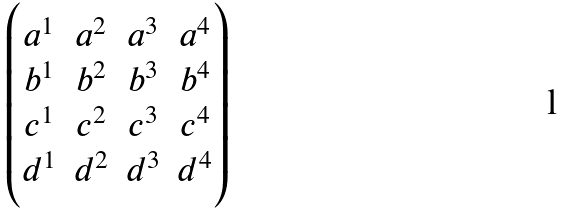Convert formula to latex. <formula><loc_0><loc_0><loc_500><loc_500>\begin{pmatrix} a ^ { 1 } & a ^ { 2 } & a ^ { 3 } & a ^ { 4 } \\ b ^ { 1 } & b ^ { 2 } & b ^ { 3 } & b ^ { 4 } \\ c ^ { 1 } & c ^ { 2 } & c ^ { 3 } & c ^ { 4 } \\ d ^ { 1 } & d ^ { 2 } & d ^ { 3 } & d ^ { 4 } \end{pmatrix}</formula> 